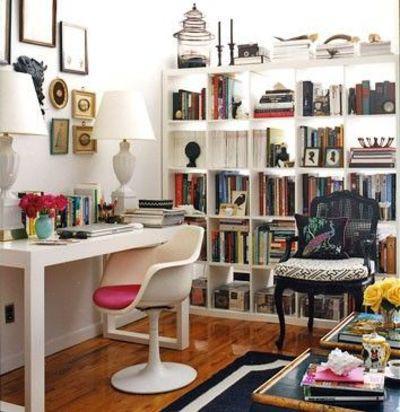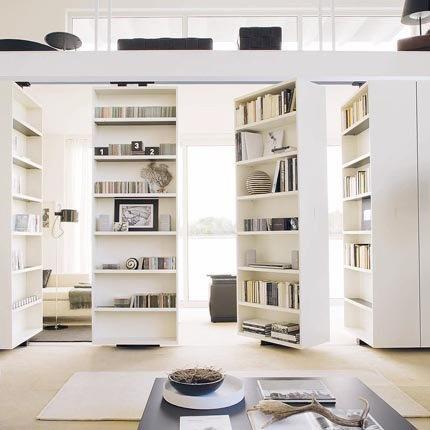The first image is the image on the left, the second image is the image on the right. Given the left and right images, does the statement "One image has a coffee table and couch in front of a book case." hold true? Answer yes or no. No. The first image is the image on the left, the second image is the image on the right. Considering the images on both sides, is "Some of the shelving is white and a vase of pink flowers is on a sofa coffee table in one of the images." valid? Answer yes or no. No. 